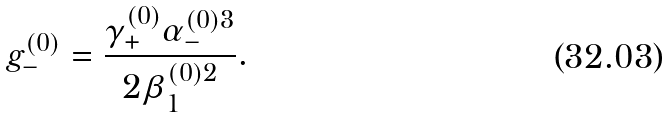Convert formula to latex. <formula><loc_0><loc_0><loc_500><loc_500>g _ { - } ^ { ( 0 ) } = \frac { \gamma _ { + } ^ { ( 0 ) } \alpha _ { - } ^ { ( 0 ) 3 } } { 2 \beta _ { 1 } ^ { ( 0 ) 2 } } .</formula> 